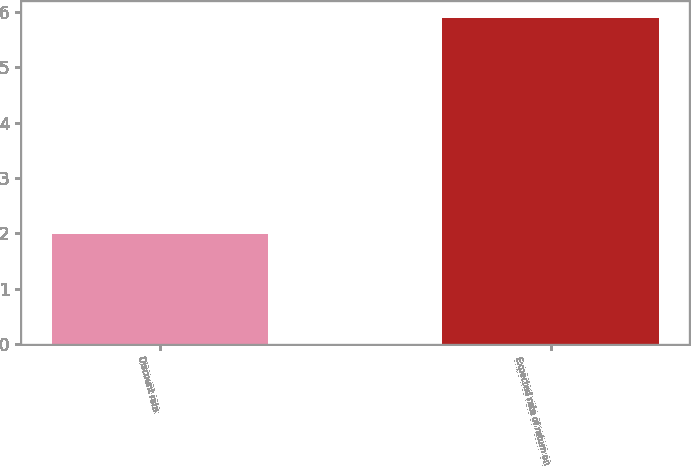Convert chart to OTSL. <chart><loc_0><loc_0><loc_500><loc_500><bar_chart><fcel>Discount rate<fcel>Expected rate of return on<nl><fcel>1.99<fcel>5.9<nl></chart> 